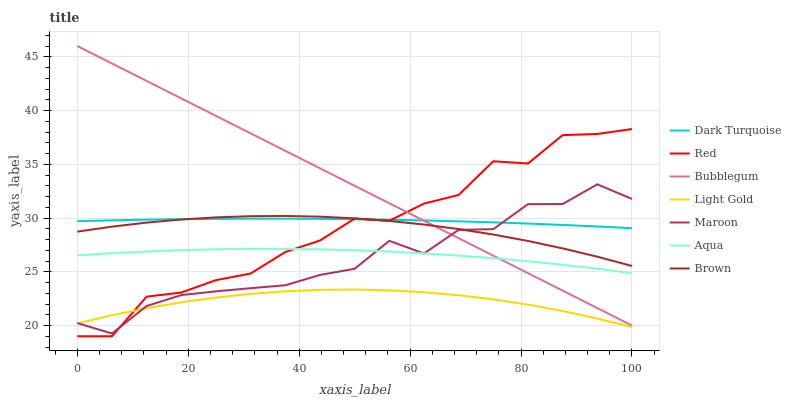Does Light Gold have the minimum area under the curve?
Answer yes or no. Yes. Does Bubblegum have the maximum area under the curve?
Answer yes or no. Yes. Does Dark Turquoise have the minimum area under the curve?
Answer yes or no. No. Does Dark Turquoise have the maximum area under the curve?
Answer yes or no. No. Is Bubblegum the smoothest?
Answer yes or no. Yes. Is Maroon the roughest?
Answer yes or no. Yes. Is Dark Turquoise the smoothest?
Answer yes or no. No. Is Dark Turquoise the roughest?
Answer yes or no. No. Does Red have the lowest value?
Answer yes or no. Yes. Does Aqua have the lowest value?
Answer yes or no. No. Does Bubblegum have the highest value?
Answer yes or no. Yes. Does Dark Turquoise have the highest value?
Answer yes or no. No. Is Light Gold less than Brown?
Answer yes or no. Yes. Is Aqua greater than Light Gold?
Answer yes or no. Yes. Does Bubblegum intersect Red?
Answer yes or no. Yes. Is Bubblegum less than Red?
Answer yes or no. No. Is Bubblegum greater than Red?
Answer yes or no. No. Does Light Gold intersect Brown?
Answer yes or no. No. 